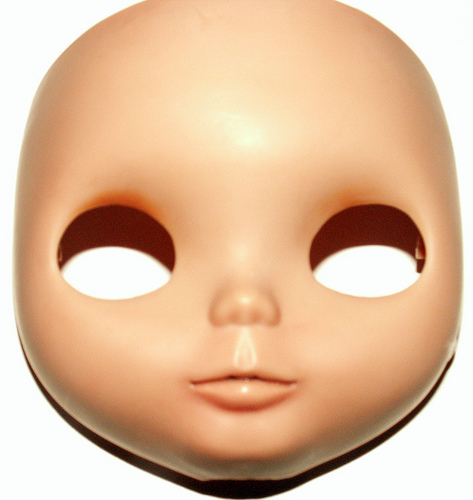<image>
Can you confirm if the eye hole is next to the eye hole? Yes. The eye hole is positioned adjacent to the eye hole, located nearby in the same general area. Where is the mask in relation to the table? Is it under the table? No. The mask is not positioned under the table. The vertical relationship between these objects is different. 